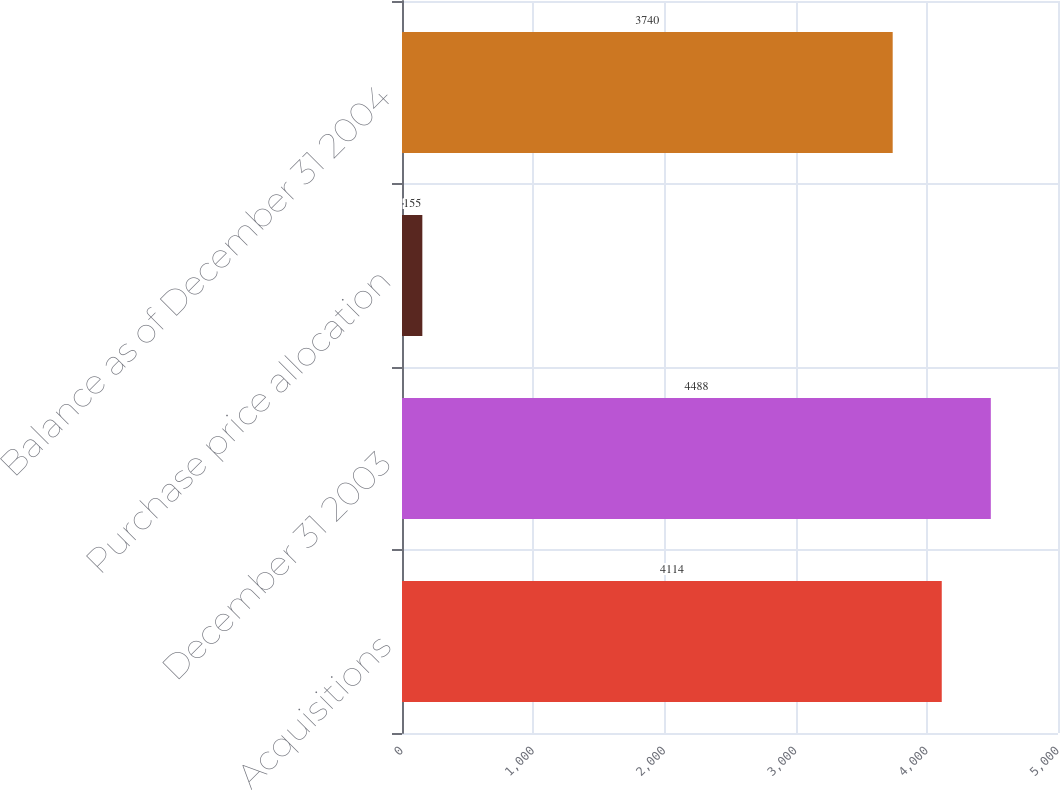Convert chart. <chart><loc_0><loc_0><loc_500><loc_500><bar_chart><fcel>Acquisitions<fcel>December 31 2003<fcel>Purchase price allocation<fcel>Balance as of December 31 2004<nl><fcel>4114<fcel>4488<fcel>155<fcel>3740<nl></chart> 